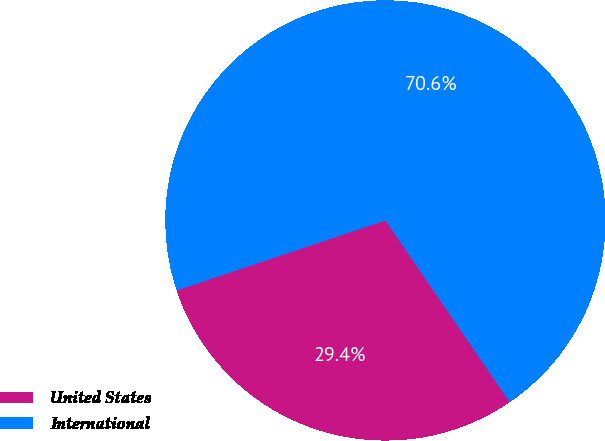<chart> <loc_0><loc_0><loc_500><loc_500><pie_chart><fcel>United States<fcel>International<nl><fcel>29.4%<fcel>70.6%<nl></chart> 